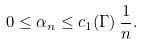<formula> <loc_0><loc_0><loc_500><loc_500>0 \leq \alpha _ { n } \leq c _ { 1 } ( \Gamma ) \, \frac { 1 } { n } .</formula> 